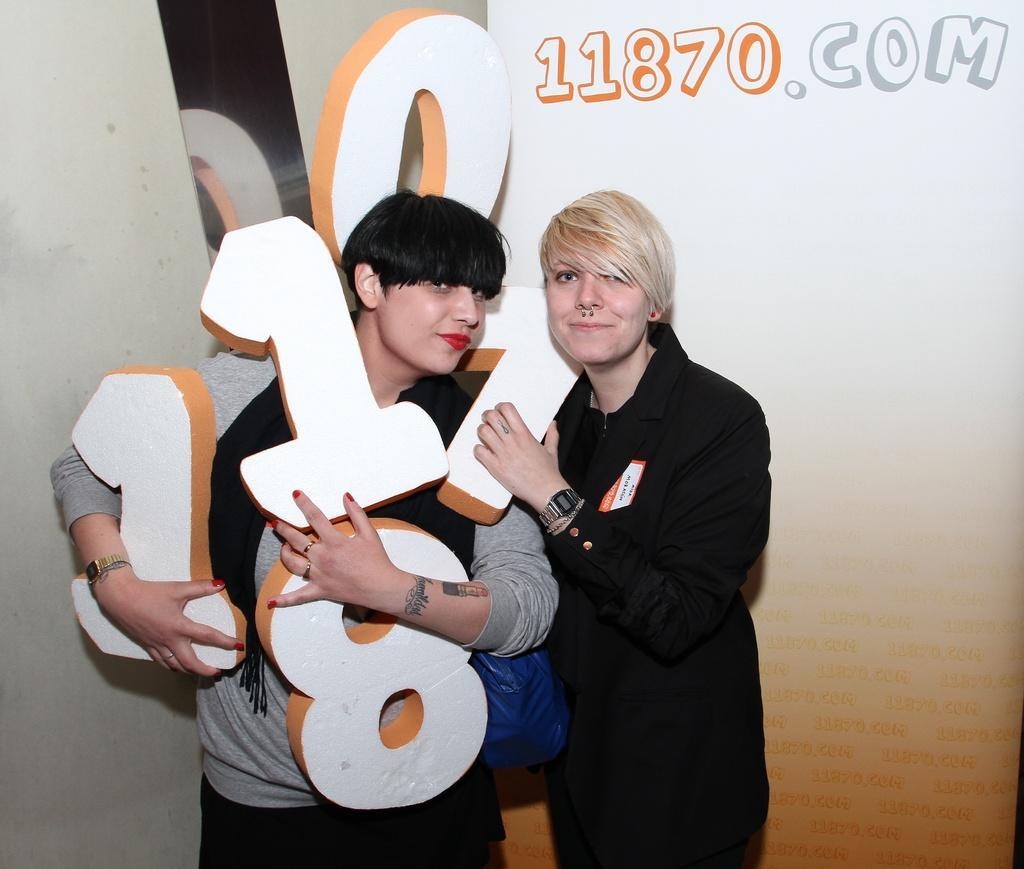In one or two sentences, can you explain what this image depicts? In this image in front there are two persons standing on the floor by holding the digits. On the backside of the image there is a wall. 